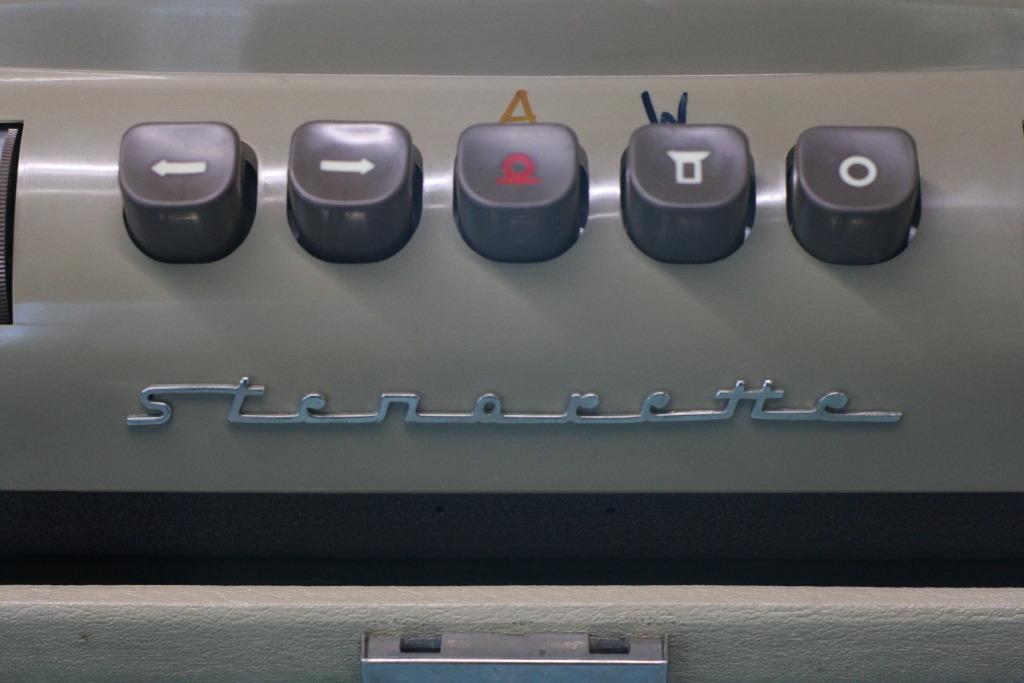Is this a computer?
Your answer should be compact. No. 